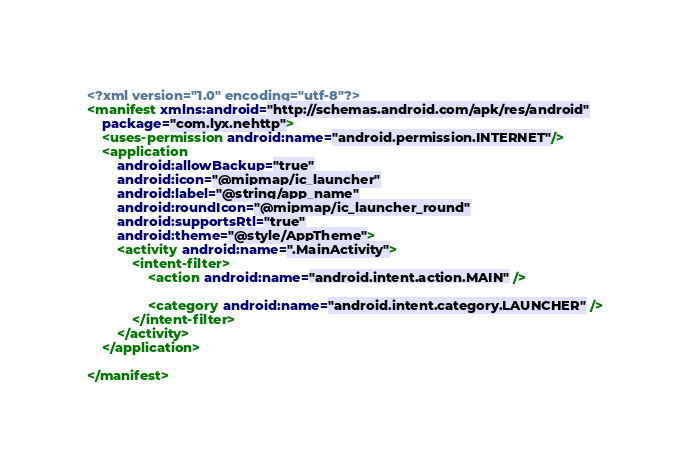Convert code to text. <code><loc_0><loc_0><loc_500><loc_500><_XML_><?xml version="1.0" encoding="utf-8"?>
<manifest xmlns:android="http://schemas.android.com/apk/res/android"
    package="com.lyx.nehttp">
    <uses-permission android:name="android.permission.INTERNET"/>
    <application
        android:allowBackup="true"
        android:icon="@mipmap/ic_launcher"
        android:label="@string/app_name"
        android:roundIcon="@mipmap/ic_launcher_round"
        android:supportsRtl="true"
        android:theme="@style/AppTheme">
        <activity android:name=".MainActivity">
            <intent-filter>
                <action android:name="android.intent.action.MAIN" />

                <category android:name="android.intent.category.LAUNCHER" />
            </intent-filter>
        </activity>
    </application>

</manifest></code> 